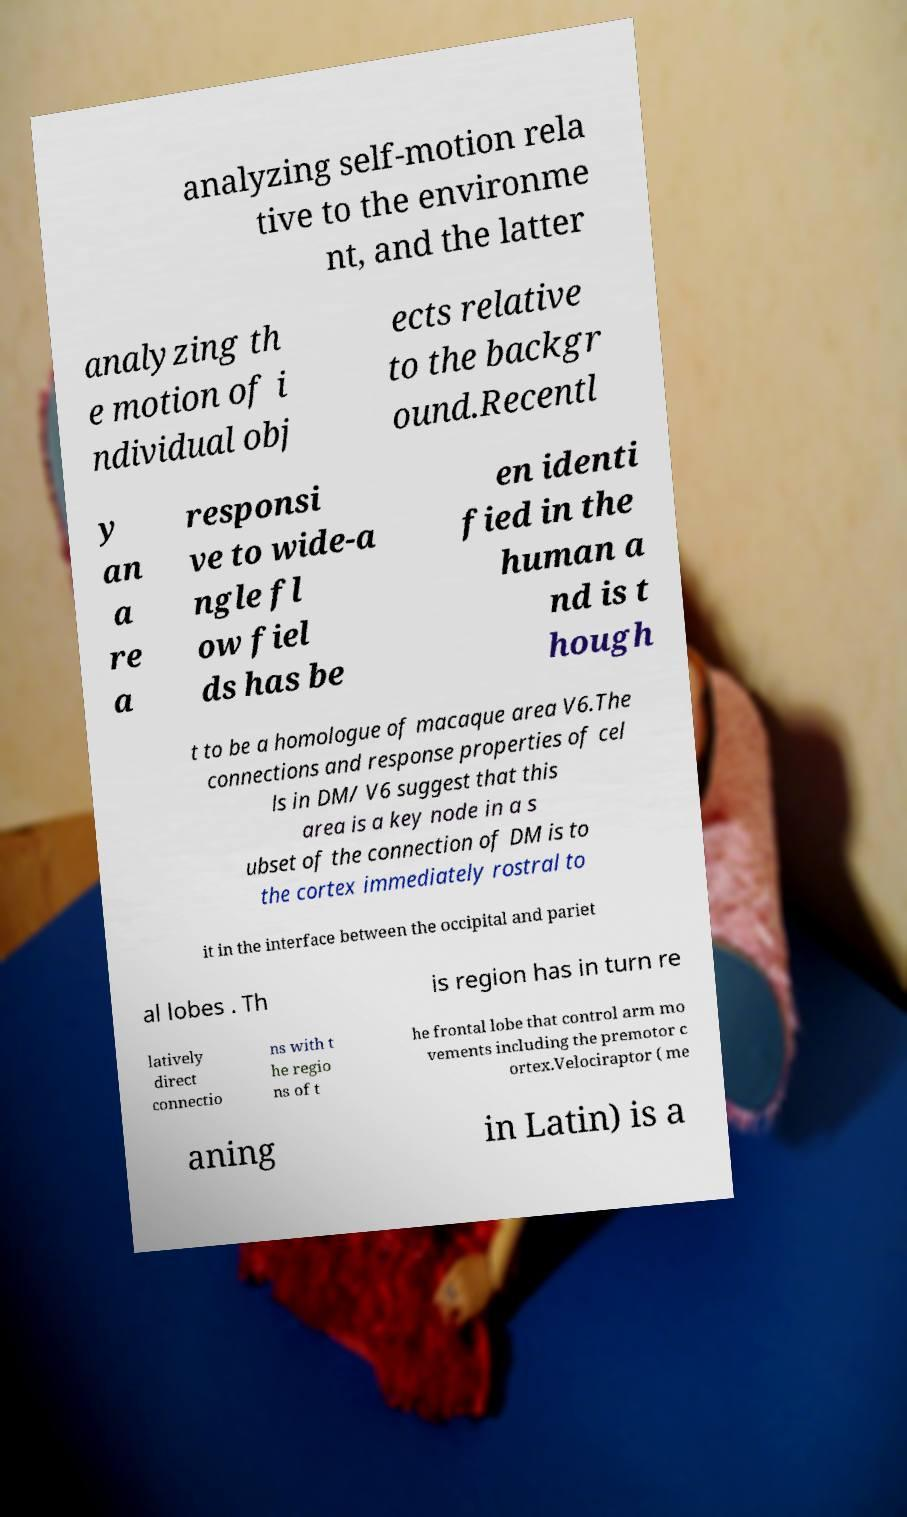I need the written content from this picture converted into text. Can you do that? analyzing self-motion rela tive to the environme nt, and the latter analyzing th e motion of i ndividual obj ects relative to the backgr ound.Recentl y an a re a responsi ve to wide-a ngle fl ow fiel ds has be en identi fied in the human a nd is t hough t to be a homologue of macaque area V6.The connections and response properties of cel ls in DM/ V6 suggest that this area is a key node in a s ubset of the connection of DM is to the cortex immediately rostral to it in the interface between the occipital and pariet al lobes . Th is region has in turn re latively direct connectio ns with t he regio ns of t he frontal lobe that control arm mo vements including the premotor c ortex.Velociraptor ( me aning in Latin) is a 